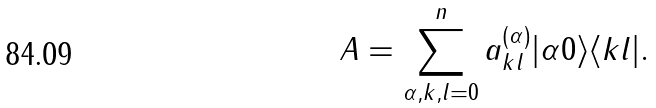Convert formula to latex. <formula><loc_0><loc_0><loc_500><loc_500>A = \sum _ { \alpha , k , l = 0 } ^ { n } a ^ { ( \alpha ) } _ { k l } | \alpha 0 \rangle \langle k l | .</formula> 